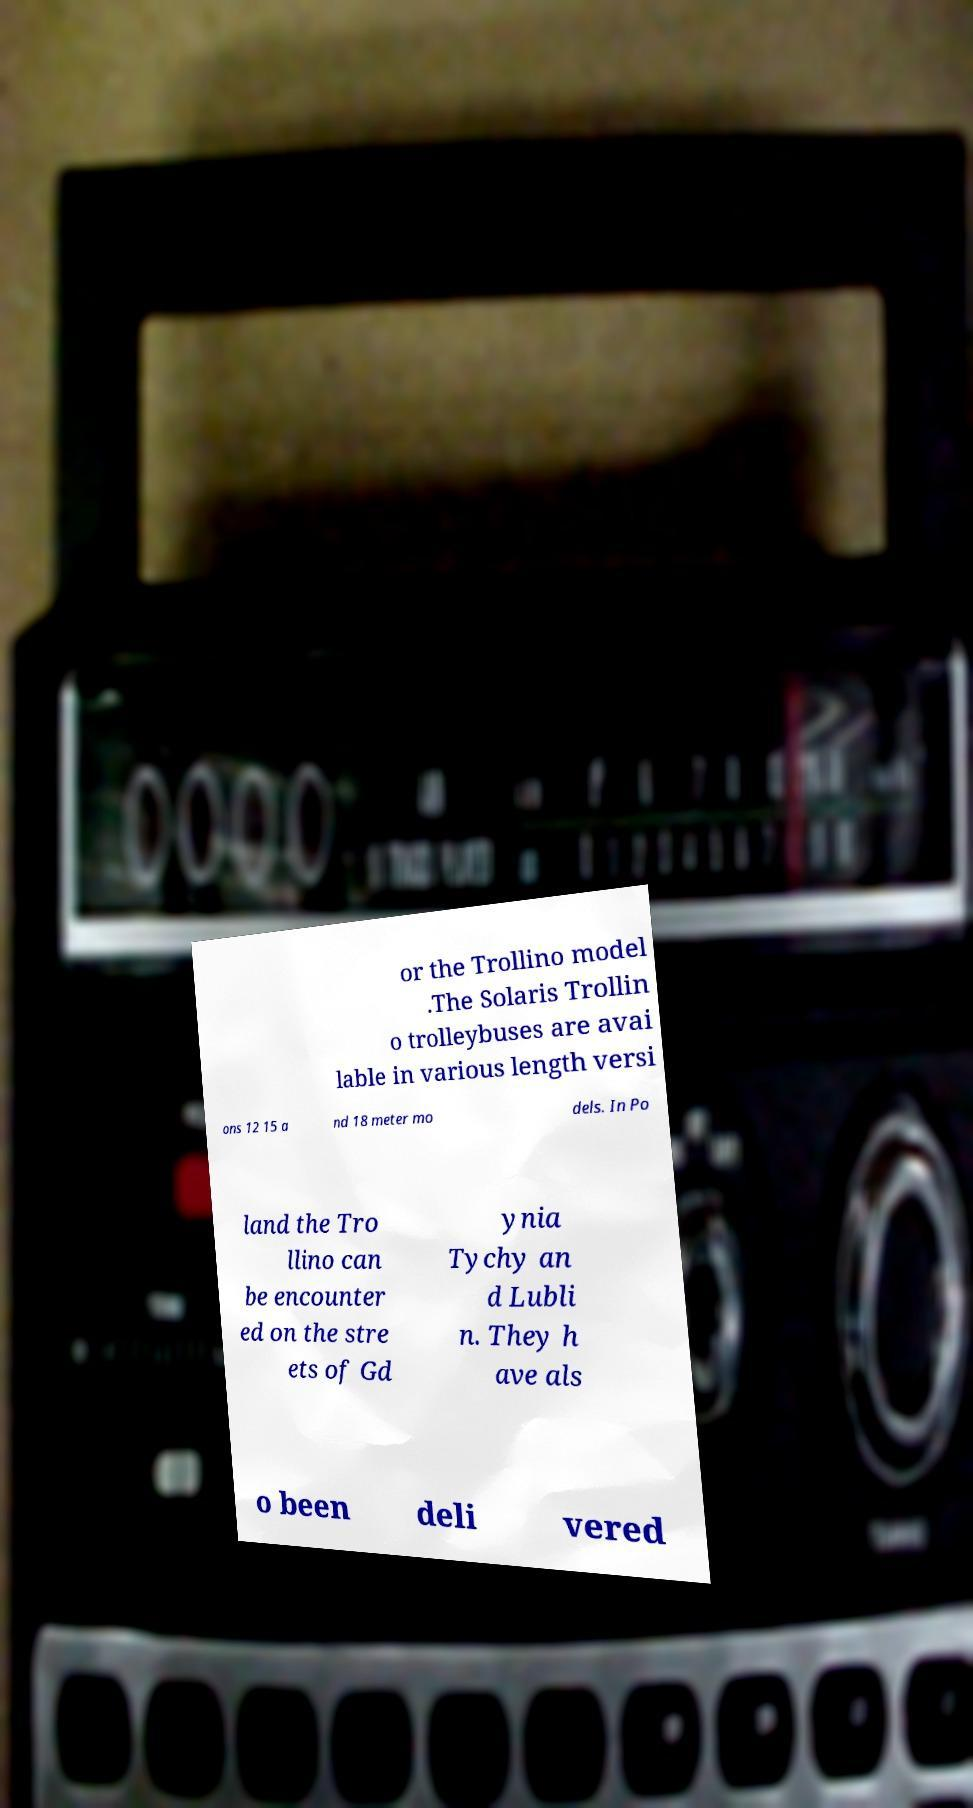Can you accurately transcribe the text from the provided image for me? or the Trollino model .The Solaris Trollin o trolleybuses are avai lable in various length versi ons 12 15 a nd 18 meter mo dels. In Po land the Tro llino can be encounter ed on the stre ets of Gd ynia Tychy an d Lubli n. They h ave als o been deli vered 